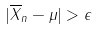Convert formula to latex. <formula><loc_0><loc_0><loc_500><loc_500>| \overline { X } _ { n } - \mu | > \epsilon</formula> 